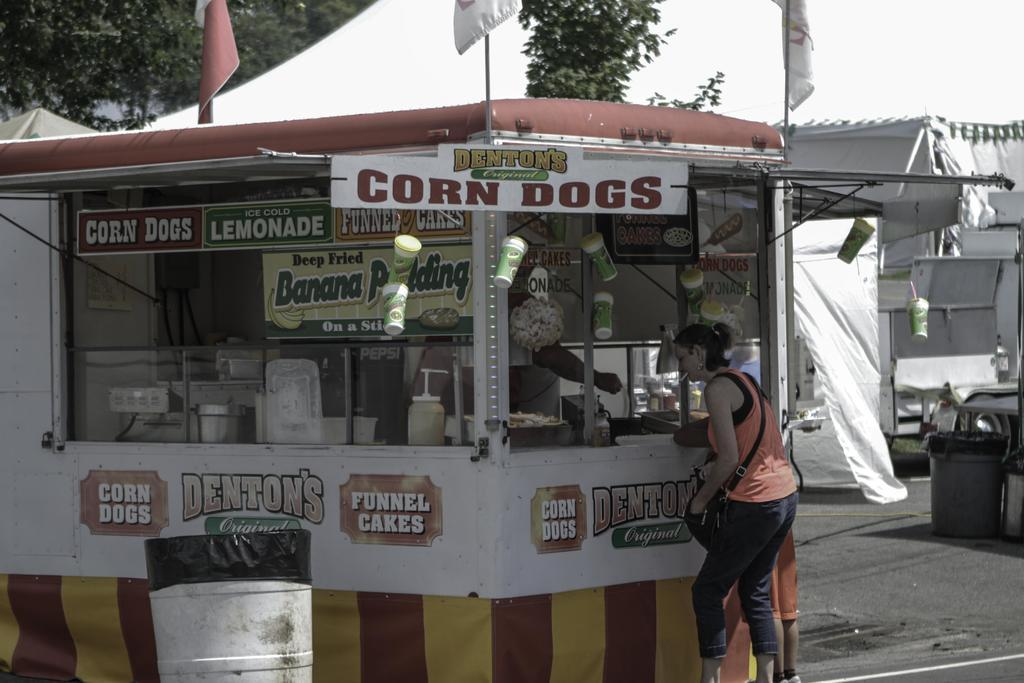What type of structure is present in the image? There is a stall in the image. What can be found near the stall? There are bins in the image. Are there any people in the image? Yes, there are people in the image. What can be seen in the background of the image? There are flags and trees in the image. What is the setting of the image? There is a road in the image, suggesting it is an outdoor location. What items are related to serving or consuming beverages in the image? There is a bottle, glasses, and boards in the image. What type of vessel is being used to transport the person in the image? There is no vessel present in the image, nor is there any indication of a person being transported. 